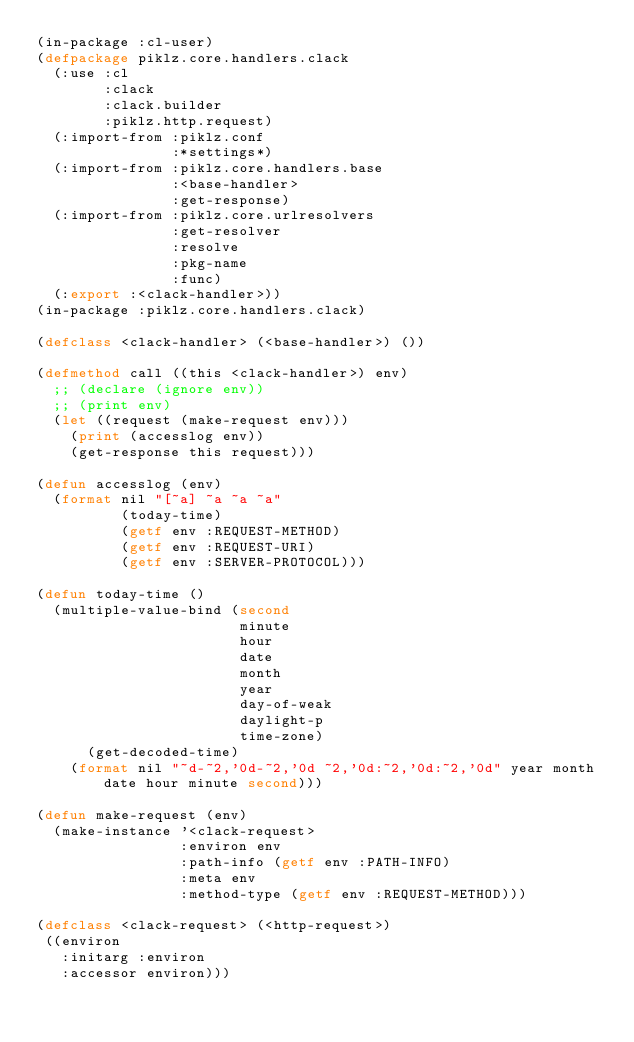<code> <loc_0><loc_0><loc_500><loc_500><_Lisp_>(in-package :cl-user)
(defpackage piklz.core.handlers.clack
  (:use :cl
        :clack
        :clack.builder
        :piklz.http.request)
  (:import-from :piklz.conf
                :*settings*)
  (:import-from :piklz.core.handlers.base
                :<base-handler>
                :get-response)
  (:import-from :piklz.core.urlresolvers
                :get-resolver
                :resolve
                :pkg-name
                :func)
  (:export :<clack-handler>))
(in-package :piklz.core.handlers.clack)

(defclass <clack-handler> (<base-handler>) ())

(defmethod call ((this <clack-handler>) env)
  ;; (declare (ignore env))
  ;; (print env)
  (let ((request (make-request env)))
    (print (accesslog env))
    (get-response this request)))

(defun accesslog (env)
  (format nil "[~a] ~a ~a ~a"
          (today-time)
          (getf env :REQUEST-METHOD)
          (getf env :REQUEST-URI)
          (getf env :SERVER-PROTOCOL)))

(defun today-time ()
  (multiple-value-bind (second
                        minute
                        hour
                        date
                        month
                        year
                        day-of-weak
                        daylight-p
                        time-zone)
      (get-decoded-time)
    (format nil "~d-~2,'0d-~2,'0d ~2,'0d:~2,'0d:~2,'0d" year month date hour minute second)))

(defun make-request (env)
  (make-instance '<clack-request>
                 :environ env
                 :path-info (getf env :PATH-INFO)
                 :meta env
                 :method-type (getf env :REQUEST-METHOD)))

(defclass <clack-request> (<http-request>)
 ((environ
   :initarg :environ
   :accessor environ)))
</code> 